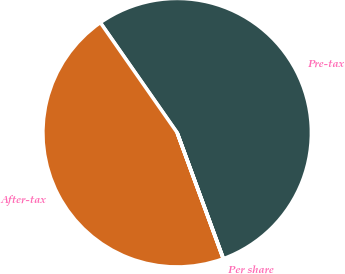Convert chart. <chart><loc_0><loc_0><loc_500><loc_500><pie_chart><fcel>Pre-tax<fcel>After-tax<fcel>Per share<nl><fcel>54.09%<fcel>45.88%<fcel>0.03%<nl></chart> 